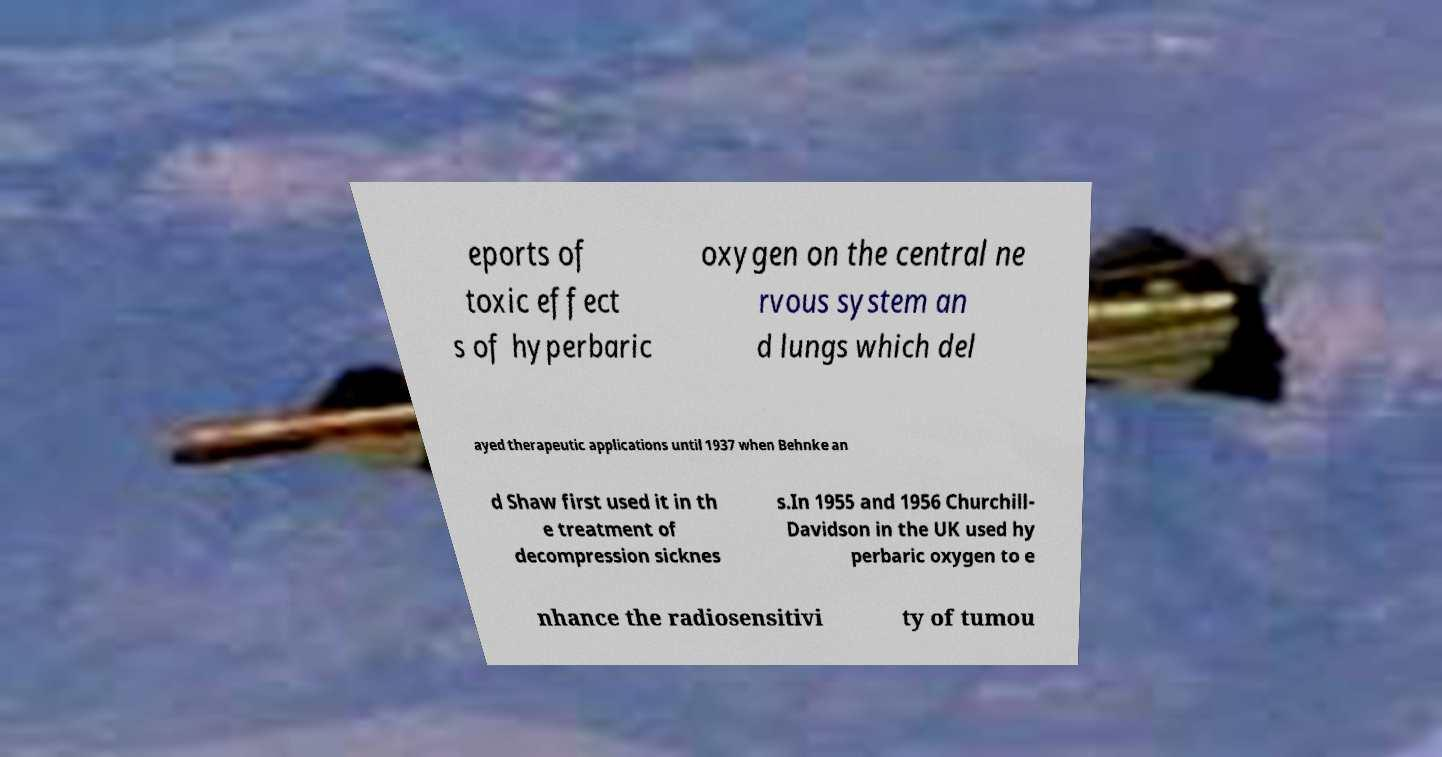Can you accurately transcribe the text from the provided image for me? eports of toxic effect s of hyperbaric oxygen on the central ne rvous system an d lungs which del ayed therapeutic applications until 1937 when Behnke an d Shaw first used it in th e treatment of decompression sicknes s.In 1955 and 1956 Churchill- Davidson in the UK used hy perbaric oxygen to e nhance the radiosensitivi ty of tumou 